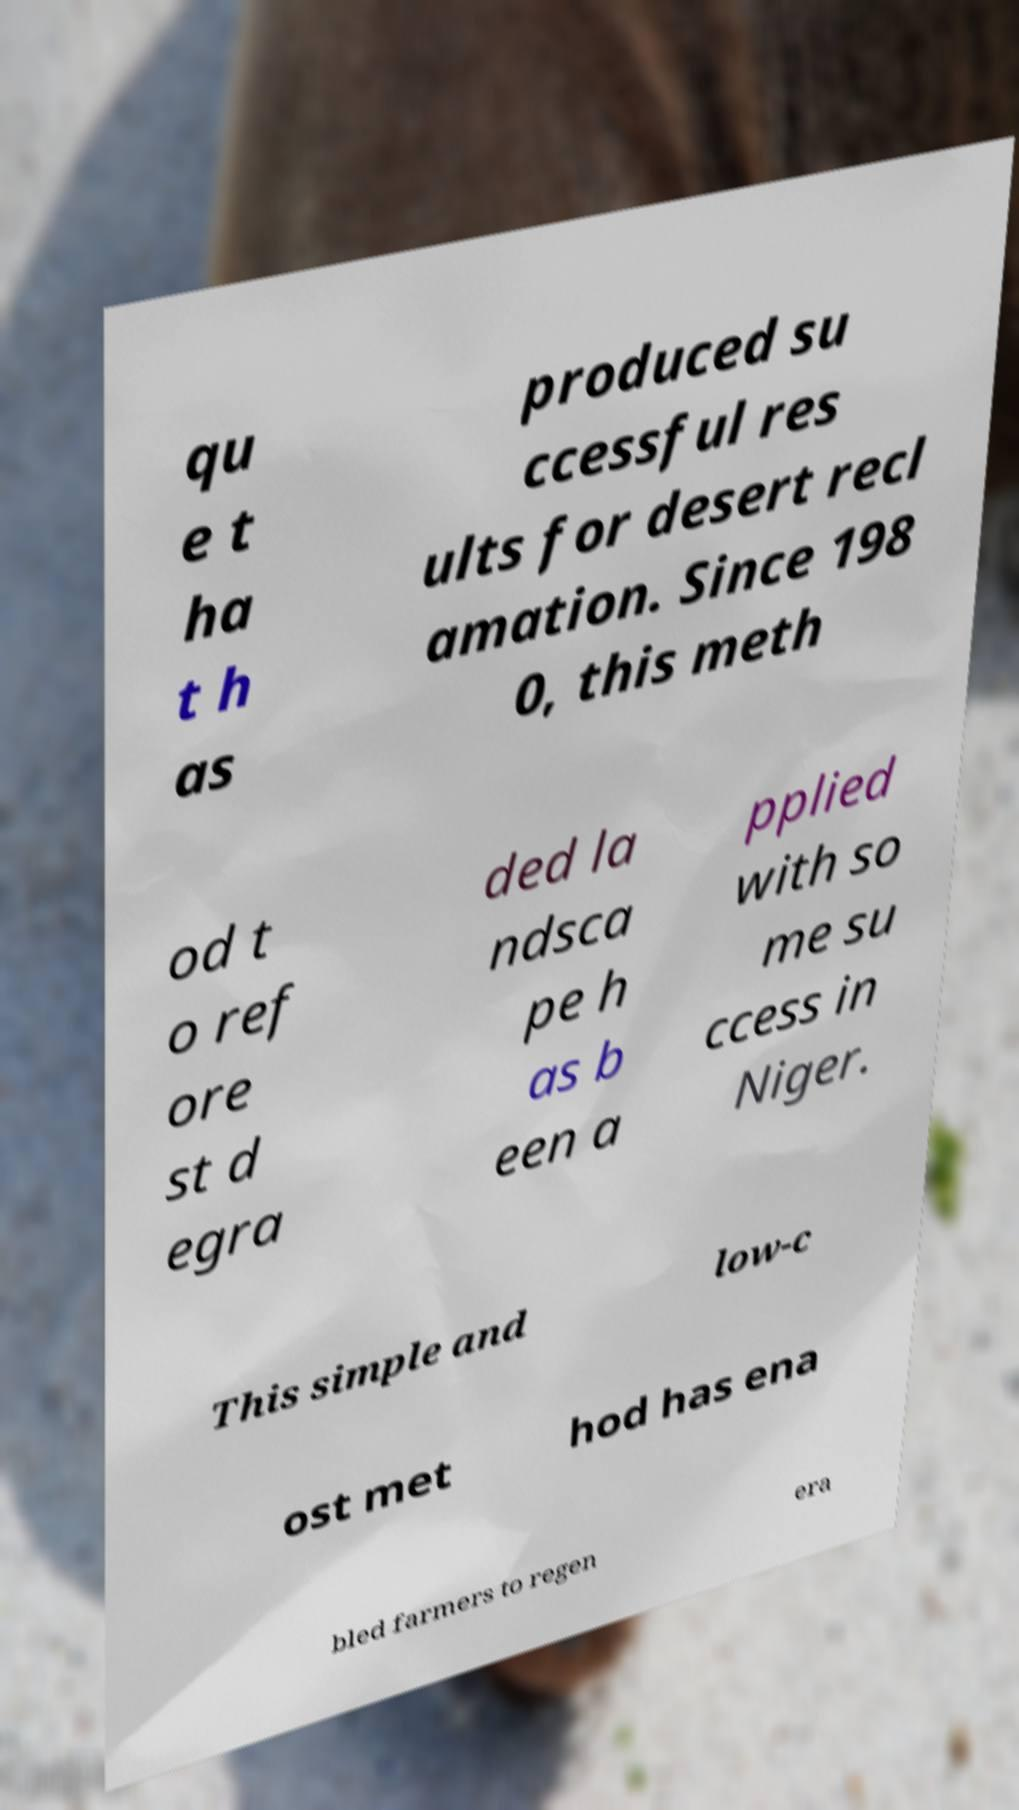Can you read and provide the text displayed in the image?This photo seems to have some interesting text. Can you extract and type it out for me? qu e t ha t h as produced su ccessful res ults for desert recl amation. Since 198 0, this meth od t o ref ore st d egra ded la ndsca pe h as b een a pplied with so me su ccess in Niger. This simple and low-c ost met hod has ena bled farmers to regen era 